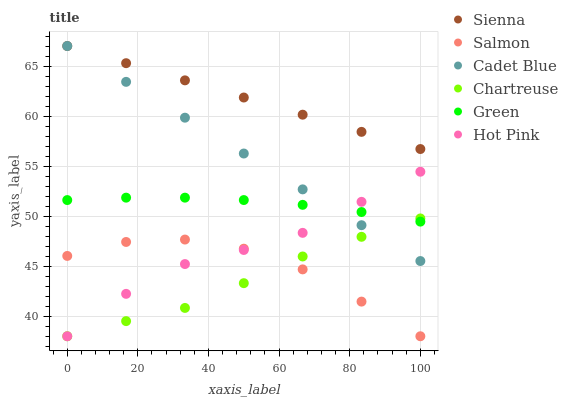Does Chartreuse have the minimum area under the curve?
Answer yes or no. Yes. Does Sienna have the maximum area under the curve?
Answer yes or no. Yes. Does Hot Pink have the minimum area under the curve?
Answer yes or no. No. Does Hot Pink have the maximum area under the curve?
Answer yes or no. No. Is Cadet Blue the smoothest?
Answer yes or no. Yes. Is Salmon the roughest?
Answer yes or no. Yes. Is Hot Pink the smoothest?
Answer yes or no. No. Is Hot Pink the roughest?
Answer yes or no. No. Does Hot Pink have the lowest value?
Answer yes or no. Yes. Does Sienna have the lowest value?
Answer yes or no. No. Does Sienna have the highest value?
Answer yes or no. Yes. Does Hot Pink have the highest value?
Answer yes or no. No. Is Salmon less than Sienna?
Answer yes or no. Yes. Is Cadet Blue greater than Salmon?
Answer yes or no. Yes. Does Cadet Blue intersect Hot Pink?
Answer yes or no. Yes. Is Cadet Blue less than Hot Pink?
Answer yes or no. No. Is Cadet Blue greater than Hot Pink?
Answer yes or no. No. Does Salmon intersect Sienna?
Answer yes or no. No. 